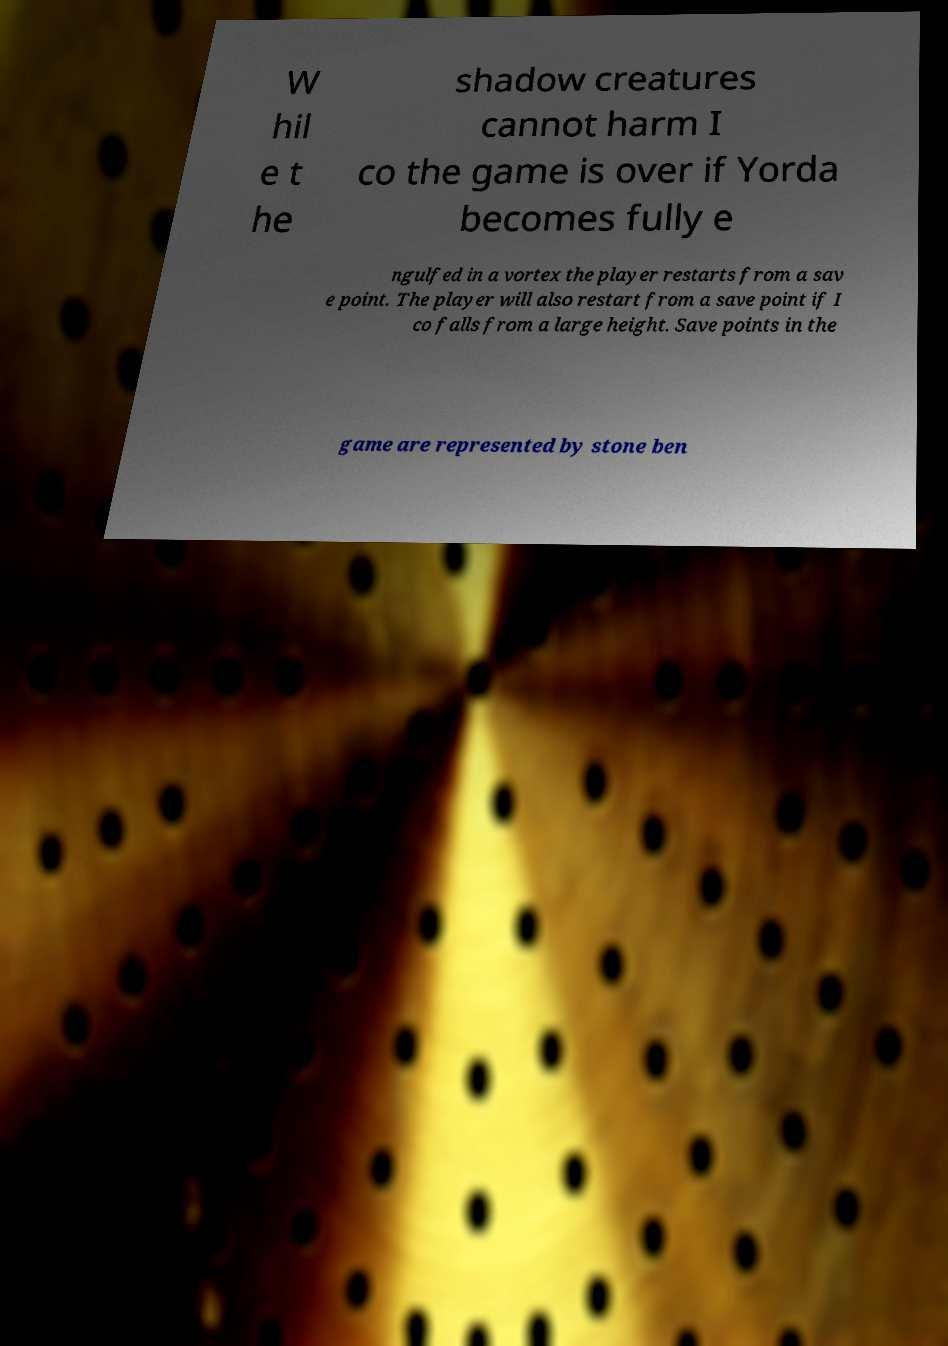I need the written content from this picture converted into text. Can you do that? W hil e t he shadow creatures cannot harm I co the game is over if Yorda becomes fully e ngulfed in a vortex the player restarts from a sav e point. The player will also restart from a save point if I co falls from a large height. Save points in the game are represented by stone ben 